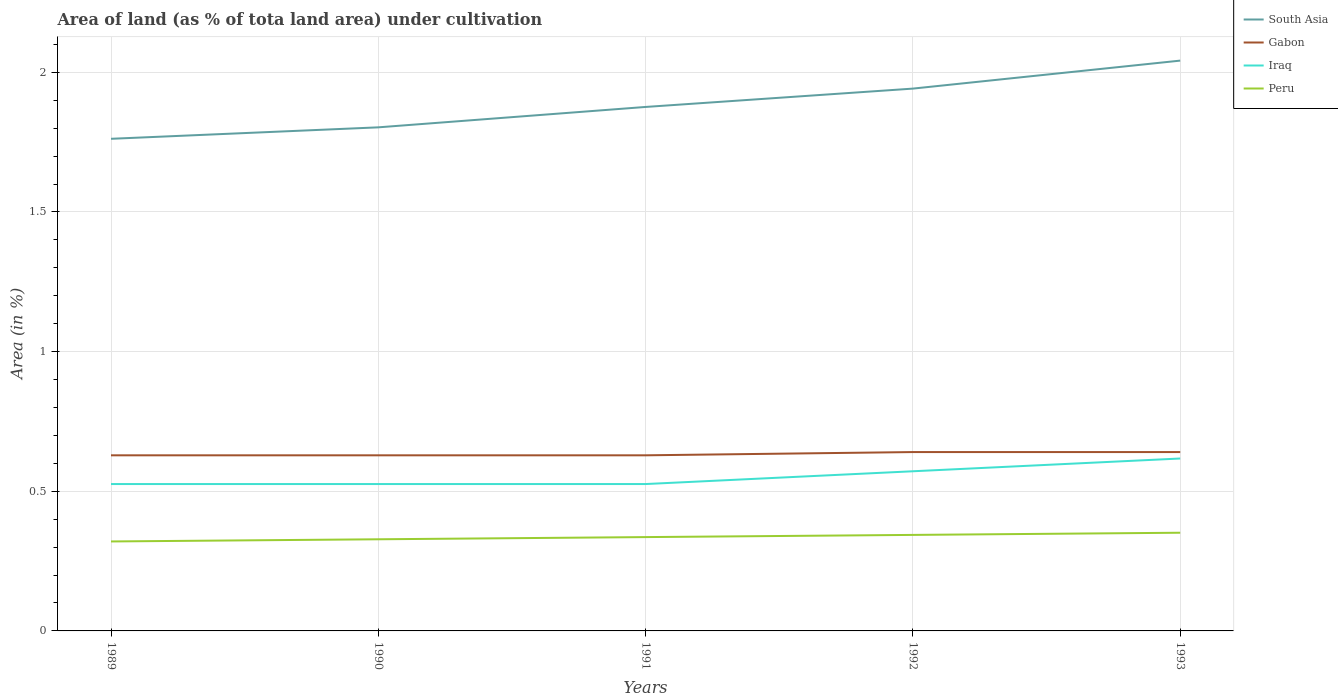Does the line corresponding to Peru intersect with the line corresponding to Gabon?
Provide a short and direct response. No. Is the number of lines equal to the number of legend labels?
Offer a terse response. Yes. Across all years, what is the maximum percentage of land under cultivation in Iraq?
Provide a short and direct response. 0.53. What is the total percentage of land under cultivation in Iraq in the graph?
Offer a very short reply. -0.05. What is the difference between the highest and the second highest percentage of land under cultivation in Iraq?
Your answer should be compact. 0.09. What is the difference between the highest and the lowest percentage of land under cultivation in Iraq?
Keep it short and to the point. 2. Is the percentage of land under cultivation in Iraq strictly greater than the percentage of land under cultivation in South Asia over the years?
Your response must be concise. Yes. How many lines are there?
Offer a terse response. 4. How many years are there in the graph?
Keep it short and to the point. 5. What is the difference between two consecutive major ticks on the Y-axis?
Your response must be concise. 0.5. Does the graph contain grids?
Provide a succinct answer. Yes. What is the title of the graph?
Keep it short and to the point. Area of land (as % of tota land area) under cultivation. What is the label or title of the X-axis?
Provide a short and direct response. Years. What is the label or title of the Y-axis?
Offer a very short reply. Area (in %). What is the Area (in %) of South Asia in 1989?
Give a very brief answer. 1.76. What is the Area (in %) in Gabon in 1989?
Give a very brief answer. 0.63. What is the Area (in %) in Iraq in 1989?
Your response must be concise. 0.53. What is the Area (in %) of Peru in 1989?
Give a very brief answer. 0.32. What is the Area (in %) of South Asia in 1990?
Your response must be concise. 1.8. What is the Area (in %) of Gabon in 1990?
Ensure brevity in your answer.  0.63. What is the Area (in %) of Iraq in 1990?
Your answer should be compact. 0.53. What is the Area (in %) in Peru in 1990?
Your response must be concise. 0.33. What is the Area (in %) in South Asia in 1991?
Ensure brevity in your answer.  1.88. What is the Area (in %) in Gabon in 1991?
Provide a short and direct response. 0.63. What is the Area (in %) of Iraq in 1991?
Keep it short and to the point. 0.53. What is the Area (in %) in Peru in 1991?
Your response must be concise. 0.34. What is the Area (in %) of South Asia in 1992?
Provide a short and direct response. 1.94. What is the Area (in %) of Gabon in 1992?
Your response must be concise. 0.64. What is the Area (in %) in Iraq in 1992?
Make the answer very short. 0.57. What is the Area (in %) of Peru in 1992?
Make the answer very short. 0.34. What is the Area (in %) in South Asia in 1993?
Offer a terse response. 2.04. What is the Area (in %) in Gabon in 1993?
Make the answer very short. 0.64. What is the Area (in %) of Iraq in 1993?
Your answer should be very brief. 0.62. What is the Area (in %) of Peru in 1993?
Your answer should be compact. 0.35. Across all years, what is the maximum Area (in %) of South Asia?
Your answer should be compact. 2.04. Across all years, what is the maximum Area (in %) of Gabon?
Provide a short and direct response. 0.64. Across all years, what is the maximum Area (in %) in Iraq?
Make the answer very short. 0.62. Across all years, what is the maximum Area (in %) in Peru?
Provide a short and direct response. 0.35. Across all years, what is the minimum Area (in %) of South Asia?
Provide a short and direct response. 1.76. Across all years, what is the minimum Area (in %) of Gabon?
Give a very brief answer. 0.63. Across all years, what is the minimum Area (in %) in Iraq?
Keep it short and to the point. 0.53. Across all years, what is the minimum Area (in %) of Peru?
Keep it short and to the point. 0.32. What is the total Area (in %) of South Asia in the graph?
Your answer should be very brief. 9.42. What is the total Area (in %) in Gabon in the graph?
Your answer should be compact. 3.17. What is the total Area (in %) of Iraq in the graph?
Your answer should be compact. 2.77. What is the total Area (in %) in Peru in the graph?
Offer a terse response. 1.68. What is the difference between the Area (in %) of South Asia in 1989 and that in 1990?
Provide a succinct answer. -0.04. What is the difference between the Area (in %) of Gabon in 1989 and that in 1990?
Keep it short and to the point. 0. What is the difference between the Area (in %) of Iraq in 1989 and that in 1990?
Give a very brief answer. 0. What is the difference between the Area (in %) of Peru in 1989 and that in 1990?
Offer a very short reply. -0.01. What is the difference between the Area (in %) in South Asia in 1989 and that in 1991?
Give a very brief answer. -0.11. What is the difference between the Area (in %) in Iraq in 1989 and that in 1991?
Your response must be concise. 0. What is the difference between the Area (in %) in Peru in 1989 and that in 1991?
Provide a short and direct response. -0.02. What is the difference between the Area (in %) of South Asia in 1989 and that in 1992?
Offer a terse response. -0.18. What is the difference between the Area (in %) of Gabon in 1989 and that in 1992?
Keep it short and to the point. -0.01. What is the difference between the Area (in %) in Iraq in 1989 and that in 1992?
Your response must be concise. -0.05. What is the difference between the Area (in %) in Peru in 1989 and that in 1992?
Offer a very short reply. -0.02. What is the difference between the Area (in %) in South Asia in 1989 and that in 1993?
Provide a succinct answer. -0.28. What is the difference between the Area (in %) of Gabon in 1989 and that in 1993?
Ensure brevity in your answer.  -0.01. What is the difference between the Area (in %) in Iraq in 1989 and that in 1993?
Your answer should be compact. -0.09. What is the difference between the Area (in %) of Peru in 1989 and that in 1993?
Provide a succinct answer. -0.03. What is the difference between the Area (in %) of South Asia in 1990 and that in 1991?
Make the answer very short. -0.07. What is the difference between the Area (in %) in Peru in 1990 and that in 1991?
Ensure brevity in your answer.  -0.01. What is the difference between the Area (in %) of South Asia in 1990 and that in 1992?
Keep it short and to the point. -0.14. What is the difference between the Area (in %) of Gabon in 1990 and that in 1992?
Provide a succinct answer. -0.01. What is the difference between the Area (in %) in Iraq in 1990 and that in 1992?
Provide a short and direct response. -0.05. What is the difference between the Area (in %) of Peru in 1990 and that in 1992?
Ensure brevity in your answer.  -0.02. What is the difference between the Area (in %) in South Asia in 1990 and that in 1993?
Keep it short and to the point. -0.24. What is the difference between the Area (in %) of Gabon in 1990 and that in 1993?
Your answer should be very brief. -0.01. What is the difference between the Area (in %) in Iraq in 1990 and that in 1993?
Keep it short and to the point. -0.09. What is the difference between the Area (in %) in Peru in 1990 and that in 1993?
Provide a short and direct response. -0.02. What is the difference between the Area (in %) of South Asia in 1991 and that in 1992?
Provide a succinct answer. -0.07. What is the difference between the Area (in %) of Gabon in 1991 and that in 1992?
Offer a very short reply. -0.01. What is the difference between the Area (in %) of Iraq in 1991 and that in 1992?
Your answer should be very brief. -0.05. What is the difference between the Area (in %) in Peru in 1991 and that in 1992?
Provide a short and direct response. -0.01. What is the difference between the Area (in %) in South Asia in 1991 and that in 1993?
Keep it short and to the point. -0.17. What is the difference between the Area (in %) of Gabon in 1991 and that in 1993?
Your answer should be compact. -0.01. What is the difference between the Area (in %) of Iraq in 1991 and that in 1993?
Make the answer very short. -0.09. What is the difference between the Area (in %) of Peru in 1991 and that in 1993?
Your response must be concise. -0.02. What is the difference between the Area (in %) in South Asia in 1992 and that in 1993?
Provide a succinct answer. -0.1. What is the difference between the Area (in %) of Gabon in 1992 and that in 1993?
Give a very brief answer. 0. What is the difference between the Area (in %) of Iraq in 1992 and that in 1993?
Give a very brief answer. -0.05. What is the difference between the Area (in %) of Peru in 1992 and that in 1993?
Your response must be concise. -0.01. What is the difference between the Area (in %) of South Asia in 1989 and the Area (in %) of Gabon in 1990?
Ensure brevity in your answer.  1.13. What is the difference between the Area (in %) of South Asia in 1989 and the Area (in %) of Iraq in 1990?
Ensure brevity in your answer.  1.24. What is the difference between the Area (in %) of South Asia in 1989 and the Area (in %) of Peru in 1990?
Keep it short and to the point. 1.43. What is the difference between the Area (in %) of Gabon in 1989 and the Area (in %) of Iraq in 1990?
Ensure brevity in your answer.  0.1. What is the difference between the Area (in %) in Gabon in 1989 and the Area (in %) in Peru in 1990?
Provide a succinct answer. 0.3. What is the difference between the Area (in %) of Iraq in 1989 and the Area (in %) of Peru in 1990?
Keep it short and to the point. 0.2. What is the difference between the Area (in %) in South Asia in 1989 and the Area (in %) in Gabon in 1991?
Your response must be concise. 1.13. What is the difference between the Area (in %) of South Asia in 1989 and the Area (in %) of Iraq in 1991?
Make the answer very short. 1.24. What is the difference between the Area (in %) of South Asia in 1989 and the Area (in %) of Peru in 1991?
Give a very brief answer. 1.43. What is the difference between the Area (in %) of Gabon in 1989 and the Area (in %) of Iraq in 1991?
Give a very brief answer. 0.1. What is the difference between the Area (in %) of Gabon in 1989 and the Area (in %) of Peru in 1991?
Make the answer very short. 0.29. What is the difference between the Area (in %) in Iraq in 1989 and the Area (in %) in Peru in 1991?
Make the answer very short. 0.19. What is the difference between the Area (in %) in South Asia in 1989 and the Area (in %) in Gabon in 1992?
Your answer should be compact. 1.12. What is the difference between the Area (in %) in South Asia in 1989 and the Area (in %) in Iraq in 1992?
Provide a short and direct response. 1.19. What is the difference between the Area (in %) in South Asia in 1989 and the Area (in %) in Peru in 1992?
Offer a terse response. 1.42. What is the difference between the Area (in %) in Gabon in 1989 and the Area (in %) in Iraq in 1992?
Give a very brief answer. 0.06. What is the difference between the Area (in %) of Gabon in 1989 and the Area (in %) of Peru in 1992?
Provide a short and direct response. 0.28. What is the difference between the Area (in %) in Iraq in 1989 and the Area (in %) in Peru in 1992?
Make the answer very short. 0.18. What is the difference between the Area (in %) in South Asia in 1989 and the Area (in %) in Gabon in 1993?
Your response must be concise. 1.12. What is the difference between the Area (in %) in South Asia in 1989 and the Area (in %) in Iraq in 1993?
Provide a succinct answer. 1.14. What is the difference between the Area (in %) of South Asia in 1989 and the Area (in %) of Peru in 1993?
Your answer should be compact. 1.41. What is the difference between the Area (in %) of Gabon in 1989 and the Area (in %) of Iraq in 1993?
Your answer should be compact. 0.01. What is the difference between the Area (in %) in Gabon in 1989 and the Area (in %) in Peru in 1993?
Your answer should be very brief. 0.28. What is the difference between the Area (in %) of Iraq in 1989 and the Area (in %) of Peru in 1993?
Make the answer very short. 0.17. What is the difference between the Area (in %) in South Asia in 1990 and the Area (in %) in Gabon in 1991?
Give a very brief answer. 1.17. What is the difference between the Area (in %) in South Asia in 1990 and the Area (in %) in Iraq in 1991?
Keep it short and to the point. 1.28. What is the difference between the Area (in %) in South Asia in 1990 and the Area (in %) in Peru in 1991?
Your answer should be compact. 1.47. What is the difference between the Area (in %) of Gabon in 1990 and the Area (in %) of Iraq in 1991?
Ensure brevity in your answer.  0.1. What is the difference between the Area (in %) in Gabon in 1990 and the Area (in %) in Peru in 1991?
Keep it short and to the point. 0.29. What is the difference between the Area (in %) of Iraq in 1990 and the Area (in %) of Peru in 1991?
Offer a terse response. 0.19. What is the difference between the Area (in %) of South Asia in 1990 and the Area (in %) of Gabon in 1992?
Make the answer very short. 1.16. What is the difference between the Area (in %) in South Asia in 1990 and the Area (in %) in Iraq in 1992?
Provide a short and direct response. 1.23. What is the difference between the Area (in %) of South Asia in 1990 and the Area (in %) of Peru in 1992?
Provide a short and direct response. 1.46. What is the difference between the Area (in %) in Gabon in 1990 and the Area (in %) in Iraq in 1992?
Provide a short and direct response. 0.06. What is the difference between the Area (in %) in Gabon in 1990 and the Area (in %) in Peru in 1992?
Your response must be concise. 0.28. What is the difference between the Area (in %) of Iraq in 1990 and the Area (in %) of Peru in 1992?
Provide a short and direct response. 0.18. What is the difference between the Area (in %) of South Asia in 1990 and the Area (in %) of Gabon in 1993?
Ensure brevity in your answer.  1.16. What is the difference between the Area (in %) in South Asia in 1990 and the Area (in %) in Iraq in 1993?
Offer a very short reply. 1.19. What is the difference between the Area (in %) of South Asia in 1990 and the Area (in %) of Peru in 1993?
Keep it short and to the point. 1.45. What is the difference between the Area (in %) of Gabon in 1990 and the Area (in %) of Iraq in 1993?
Provide a succinct answer. 0.01. What is the difference between the Area (in %) of Gabon in 1990 and the Area (in %) of Peru in 1993?
Your answer should be compact. 0.28. What is the difference between the Area (in %) of Iraq in 1990 and the Area (in %) of Peru in 1993?
Ensure brevity in your answer.  0.17. What is the difference between the Area (in %) of South Asia in 1991 and the Area (in %) of Gabon in 1992?
Your answer should be compact. 1.24. What is the difference between the Area (in %) of South Asia in 1991 and the Area (in %) of Iraq in 1992?
Ensure brevity in your answer.  1.3. What is the difference between the Area (in %) in South Asia in 1991 and the Area (in %) in Peru in 1992?
Offer a very short reply. 1.53. What is the difference between the Area (in %) of Gabon in 1991 and the Area (in %) of Iraq in 1992?
Offer a terse response. 0.06. What is the difference between the Area (in %) of Gabon in 1991 and the Area (in %) of Peru in 1992?
Make the answer very short. 0.28. What is the difference between the Area (in %) in Iraq in 1991 and the Area (in %) in Peru in 1992?
Keep it short and to the point. 0.18. What is the difference between the Area (in %) in South Asia in 1991 and the Area (in %) in Gabon in 1993?
Provide a succinct answer. 1.24. What is the difference between the Area (in %) of South Asia in 1991 and the Area (in %) of Iraq in 1993?
Provide a short and direct response. 1.26. What is the difference between the Area (in %) of South Asia in 1991 and the Area (in %) of Peru in 1993?
Your answer should be very brief. 1.52. What is the difference between the Area (in %) of Gabon in 1991 and the Area (in %) of Iraq in 1993?
Offer a very short reply. 0.01. What is the difference between the Area (in %) of Gabon in 1991 and the Area (in %) of Peru in 1993?
Make the answer very short. 0.28. What is the difference between the Area (in %) in Iraq in 1991 and the Area (in %) in Peru in 1993?
Make the answer very short. 0.17. What is the difference between the Area (in %) of South Asia in 1992 and the Area (in %) of Gabon in 1993?
Offer a terse response. 1.3. What is the difference between the Area (in %) of South Asia in 1992 and the Area (in %) of Iraq in 1993?
Keep it short and to the point. 1.32. What is the difference between the Area (in %) in South Asia in 1992 and the Area (in %) in Peru in 1993?
Offer a very short reply. 1.59. What is the difference between the Area (in %) in Gabon in 1992 and the Area (in %) in Iraq in 1993?
Give a very brief answer. 0.02. What is the difference between the Area (in %) of Gabon in 1992 and the Area (in %) of Peru in 1993?
Ensure brevity in your answer.  0.29. What is the difference between the Area (in %) of Iraq in 1992 and the Area (in %) of Peru in 1993?
Ensure brevity in your answer.  0.22. What is the average Area (in %) of South Asia per year?
Offer a very short reply. 1.88. What is the average Area (in %) of Gabon per year?
Your answer should be very brief. 0.63. What is the average Area (in %) in Iraq per year?
Provide a short and direct response. 0.55. What is the average Area (in %) of Peru per year?
Ensure brevity in your answer.  0.34. In the year 1989, what is the difference between the Area (in %) of South Asia and Area (in %) of Gabon?
Your answer should be compact. 1.13. In the year 1989, what is the difference between the Area (in %) of South Asia and Area (in %) of Iraq?
Offer a very short reply. 1.24. In the year 1989, what is the difference between the Area (in %) of South Asia and Area (in %) of Peru?
Offer a very short reply. 1.44. In the year 1989, what is the difference between the Area (in %) in Gabon and Area (in %) in Iraq?
Your answer should be very brief. 0.1. In the year 1989, what is the difference between the Area (in %) of Gabon and Area (in %) of Peru?
Provide a succinct answer. 0.31. In the year 1989, what is the difference between the Area (in %) of Iraq and Area (in %) of Peru?
Keep it short and to the point. 0.21. In the year 1990, what is the difference between the Area (in %) of South Asia and Area (in %) of Gabon?
Your answer should be very brief. 1.17. In the year 1990, what is the difference between the Area (in %) of South Asia and Area (in %) of Iraq?
Your answer should be compact. 1.28. In the year 1990, what is the difference between the Area (in %) of South Asia and Area (in %) of Peru?
Provide a short and direct response. 1.47. In the year 1990, what is the difference between the Area (in %) of Gabon and Area (in %) of Iraq?
Make the answer very short. 0.1. In the year 1990, what is the difference between the Area (in %) of Gabon and Area (in %) of Peru?
Your answer should be compact. 0.3. In the year 1990, what is the difference between the Area (in %) of Iraq and Area (in %) of Peru?
Your response must be concise. 0.2. In the year 1991, what is the difference between the Area (in %) of South Asia and Area (in %) of Gabon?
Your response must be concise. 1.25. In the year 1991, what is the difference between the Area (in %) of South Asia and Area (in %) of Iraq?
Provide a succinct answer. 1.35. In the year 1991, what is the difference between the Area (in %) in South Asia and Area (in %) in Peru?
Ensure brevity in your answer.  1.54. In the year 1991, what is the difference between the Area (in %) in Gabon and Area (in %) in Iraq?
Offer a terse response. 0.1. In the year 1991, what is the difference between the Area (in %) of Gabon and Area (in %) of Peru?
Provide a succinct answer. 0.29. In the year 1991, what is the difference between the Area (in %) of Iraq and Area (in %) of Peru?
Offer a terse response. 0.19. In the year 1992, what is the difference between the Area (in %) in South Asia and Area (in %) in Gabon?
Ensure brevity in your answer.  1.3. In the year 1992, what is the difference between the Area (in %) in South Asia and Area (in %) in Iraq?
Your answer should be very brief. 1.37. In the year 1992, what is the difference between the Area (in %) in South Asia and Area (in %) in Peru?
Offer a terse response. 1.6. In the year 1992, what is the difference between the Area (in %) of Gabon and Area (in %) of Iraq?
Offer a very short reply. 0.07. In the year 1992, what is the difference between the Area (in %) of Gabon and Area (in %) of Peru?
Your answer should be compact. 0.3. In the year 1992, what is the difference between the Area (in %) in Iraq and Area (in %) in Peru?
Provide a succinct answer. 0.23. In the year 1993, what is the difference between the Area (in %) in South Asia and Area (in %) in Gabon?
Give a very brief answer. 1.4. In the year 1993, what is the difference between the Area (in %) in South Asia and Area (in %) in Iraq?
Give a very brief answer. 1.42. In the year 1993, what is the difference between the Area (in %) in South Asia and Area (in %) in Peru?
Your answer should be very brief. 1.69. In the year 1993, what is the difference between the Area (in %) of Gabon and Area (in %) of Iraq?
Offer a very short reply. 0.02. In the year 1993, what is the difference between the Area (in %) in Gabon and Area (in %) in Peru?
Your answer should be compact. 0.29. In the year 1993, what is the difference between the Area (in %) of Iraq and Area (in %) of Peru?
Offer a terse response. 0.27. What is the ratio of the Area (in %) of South Asia in 1989 to that in 1990?
Provide a short and direct response. 0.98. What is the ratio of the Area (in %) of Peru in 1989 to that in 1990?
Offer a terse response. 0.98. What is the ratio of the Area (in %) in South Asia in 1989 to that in 1991?
Make the answer very short. 0.94. What is the ratio of the Area (in %) in Gabon in 1989 to that in 1991?
Provide a short and direct response. 1. What is the ratio of the Area (in %) of Peru in 1989 to that in 1991?
Offer a terse response. 0.95. What is the ratio of the Area (in %) of South Asia in 1989 to that in 1992?
Ensure brevity in your answer.  0.91. What is the ratio of the Area (in %) in Gabon in 1989 to that in 1992?
Ensure brevity in your answer.  0.98. What is the ratio of the Area (in %) in Peru in 1989 to that in 1992?
Your answer should be very brief. 0.93. What is the ratio of the Area (in %) in South Asia in 1989 to that in 1993?
Your response must be concise. 0.86. What is the ratio of the Area (in %) in Gabon in 1989 to that in 1993?
Provide a succinct answer. 0.98. What is the ratio of the Area (in %) in Iraq in 1989 to that in 1993?
Provide a succinct answer. 0.85. What is the ratio of the Area (in %) in Peru in 1989 to that in 1993?
Offer a terse response. 0.91. What is the ratio of the Area (in %) in South Asia in 1990 to that in 1991?
Offer a very short reply. 0.96. What is the ratio of the Area (in %) in Peru in 1990 to that in 1991?
Your response must be concise. 0.98. What is the ratio of the Area (in %) in South Asia in 1990 to that in 1992?
Keep it short and to the point. 0.93. What is the ratio of the Area (in %) in Gabon in 1990 to that in 1992?
Your response must be concise. 0.98. What is the ratio of the Area (in %) of Iraq in 1990 to that in 1992?
Provide a succinct answer. 0.92. What is the ratio of the Area (in %) in Peru in 1990 to that in 1992?
Give a very brief answer. 0.95. What is the ratio of the Area (in %) in South Asia in 1990 to that in 1993?
Your response must be concise. 0.88. What is the ratio of the Area (in %) in Gabon in 1990 to that in 1993?
Offer a terse response. 0.98. What is the ratio of the Area (in %) of Iraq in 1990 to that in 1993?
Ensure brevity in your answer.  0.85. What is the ratio of the Area (in %) of Peru in 1990 to that in 1993?
Ensure brevity in your answer.  0.93. What is the ratio of the Area (in %) of South Asia in 1991 to that in 1992?
Keep it short and to the point. 0.97. What is the ratio of the Area (in %) in Gabon in 1991 to that in 1992?
Keep it short and to the point. 0.98. What is the ratio of the Area (in %) of Iraq in 1991 to that in 1992?
Your response must be concise. 0.92. What is the ratio of the Area (in %) in Peru in 1991 to that in 1992?
Your answer should be compact. 0.98. What is the ratio of the Area (in %) of South Asia in 1991 to that in 1993?
Your answer should be compact. 0.92. What is the ratio of the Area (in %) in Gabon in 1991 to that in 1993?
Your answer should be very brief. 0.98. What is the ratio of the Area (in %) in Iraq in 1991 to that in 1993?
Give a very brief answer. 0.85. What is the ratio of the Area (in %) of Peru in 1991 to that in 1993?
Provide a short and direct response. 0.96. What is the ratio of the Area (in %) of South Asia in 1992 to that in 1993?
Offer a very short reply. 0.95. What is the ratio of the Area (in %) in Iraq in 1992 to that in 1993?
Provide a short and direct response. 0.93. What is the ratio of the Area (in %) of Peru in 1992 to that in 1993?
Ensure brevity in your answer.  0.98. What is the difference between the highest and the second highest Area (in %) of South Asia?
Your answer should be very brief. 0.1. What is the difference between the highest and the second highest Area (in %) in Iraq?
Your answer should be very brief. 0.05. What is the difference between the highest and the second highest Area (in %) in Peru?
Offer a terse response. 0.01. What is the difference between the highest and the lowest Area (in %) of South Asia?
Your answer should be very brief. 0.28. What is the difference between the highest and the lowest Area (in %) in Gabon?
Give a very brief answer. 0.01. What is the difference between the highest and the lowest Area (in %) in Iraq?
Give a very brief answer. 0.09. What is the difference between the highest and the lowest Area (in %) of Peru?
Your answer should be compact. 0.03. 